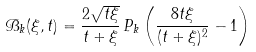<formula> <loc_0><loc_0><loc_500><loc_500>\mathcal { B } _ { k } ( \xi , t ) = \frac { 2 \sqrt { t \xi } } { t + \xi } \, P _ { k } \left ( \frac { 8 t \xi } { ( t + \xi ) ^ { 2 } } - 1 \right )</formula> 